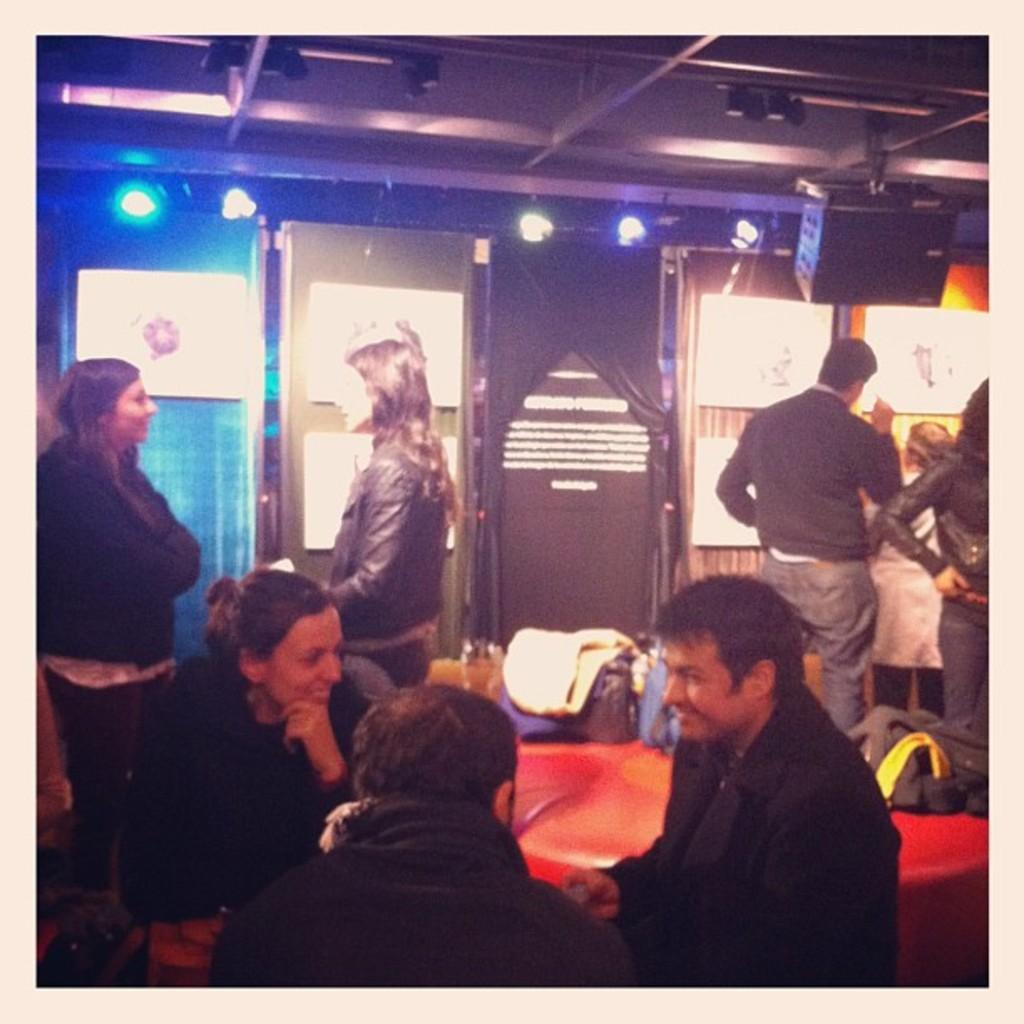Describe this image in one or two sentences. In this image we can see a group of people standing. We can also see a door, some boards on a wall, speaker boxes and a roof with some ceiling lights. On the bottom of the image we can see some people and objects which are placed on a table. 